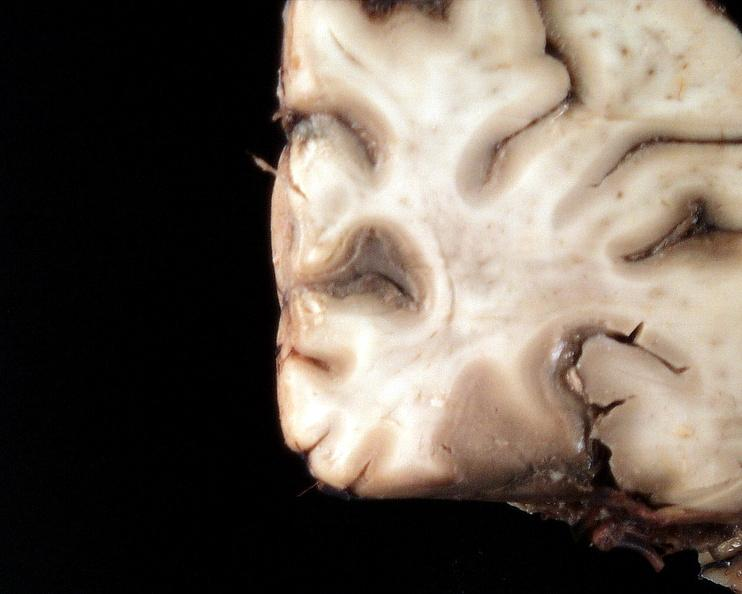does this image show brain, cryptococcal meningitis?
Answer the question using a single word or phrase. Yes 